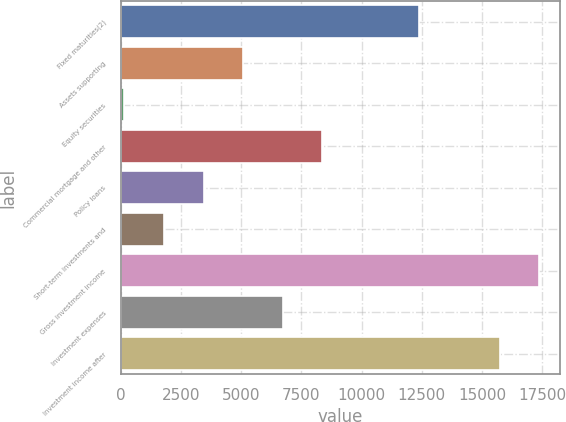<chart> <loc_0><loc_0><loc_500><loc_500><bar_chart><fcel>Fixed maturities(2)<fcel>Assets supporting<fcel>Equity securities<fcel>Commercial mortgage and other<fcel>Policy loans<fcel>Short-term investments and<fcel>Gross investment income<fcel>Investment expenses<fcel>Investment income after<nl><fcel>12403<fcel>5085.6<fcel>165<fcel>8366<fcel>3445.4<fcel>1805.2<fcel>17369.2<fcel>6725.8<fcel>15729<nl></chart> 